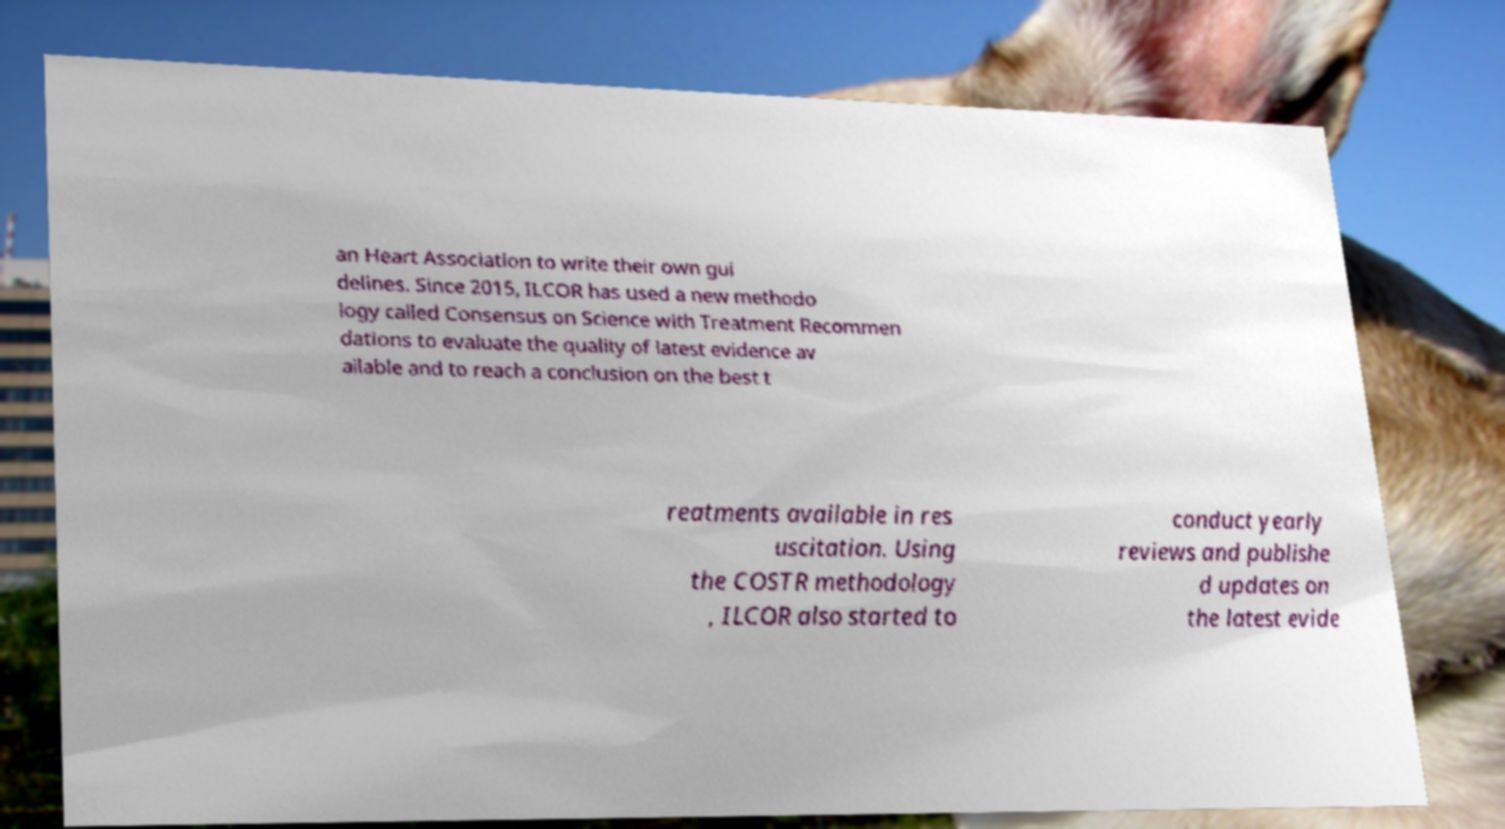Can you read and provide the text displayed in the image?This photo seems to have some interesting text. Can you extract and type it out for me? an Heart Association to write their own gui delines. Since 2015, ILCOR has used a new methodo logy called Consensus on Science with Treatment Recommen dations to evaluate the quality of latest evidence av ailable and to reach a conclusion on the best t reatments available in res uscitation. Using the COSTR methodology , ILCOR also started to conduct yearly reviews and publishe d updates on the latest evide 